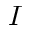<formula> <loc_0><loc_0><loc_500><loc_500>I</formula> 